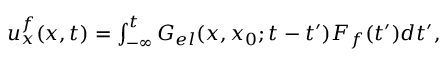<formula> <loc_0><loc_0><loc_500><loc_500>\begin{array} { r } { u _ { x } ^ { f } ( x , t ) = \int _ { - \infty } ^ { t } G _ { e l } ( x , x _ { 0 } ; t - t ^ { \prime } ) F _ { f } ( t ^ { \prime } ) d t ^ { \prime } , } \end{array}</formula> 